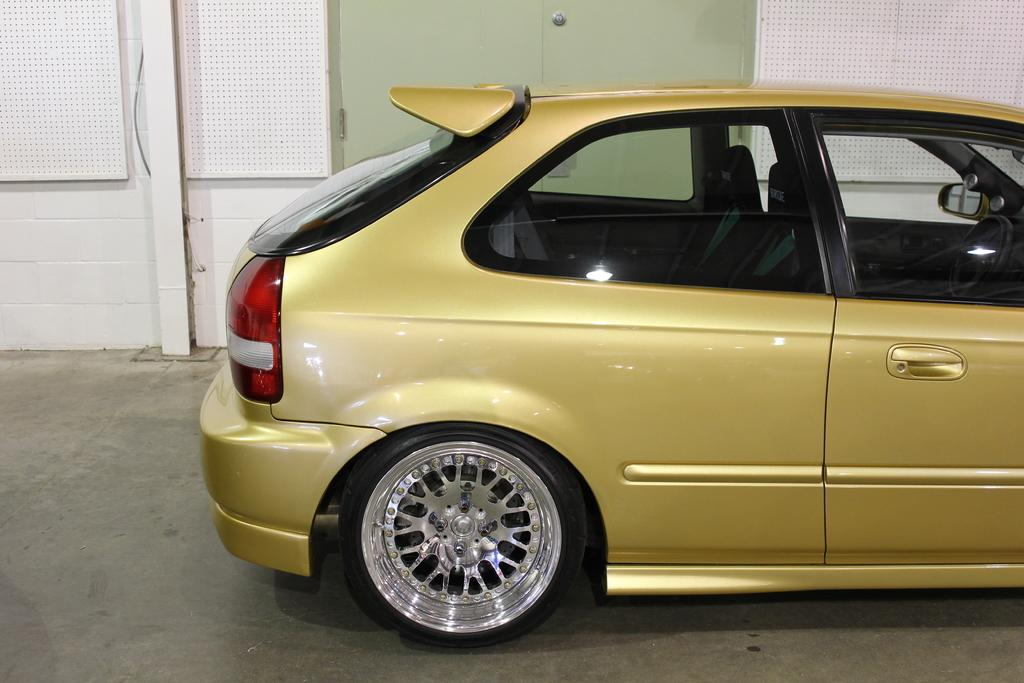What is the main subject of the image? There is a car in the image. Where is the car located in the image? The car is towards the right side of the image. What color is the car? The car is yellow in color. What can be seen behind the car in the image? There is a door to a wall behind the car. What type of advice is the car giving in the image? The car is not giving any advice in the image, as it is an inanimate object and cannot speak or provide advice. 